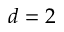<formula> <loc_0><loc_0><loc_500><loc_500>d = 2</formula> 